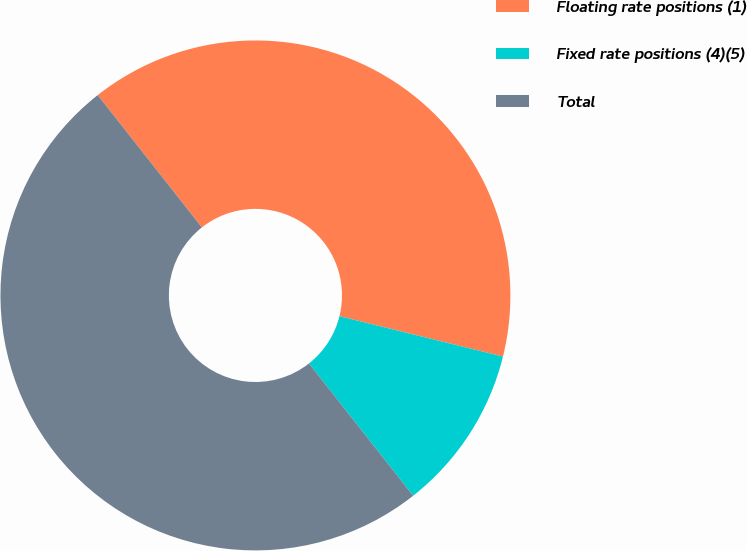<chart> <loc_0><loc_0><loc_500><loc_500><pie_chart><fcel>Floating rate positions (1)<fcel>Fixed rate positions (4)(5)<fcel>Total<nl><fcel>39.47%<fcel>10.53%<fcel>50.0%<nl></chart> 